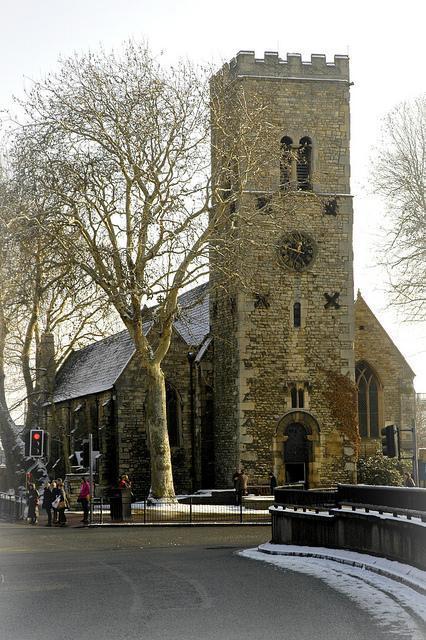How many feet does the right zebra have on the ground?
Give a very brief answer. 0. 